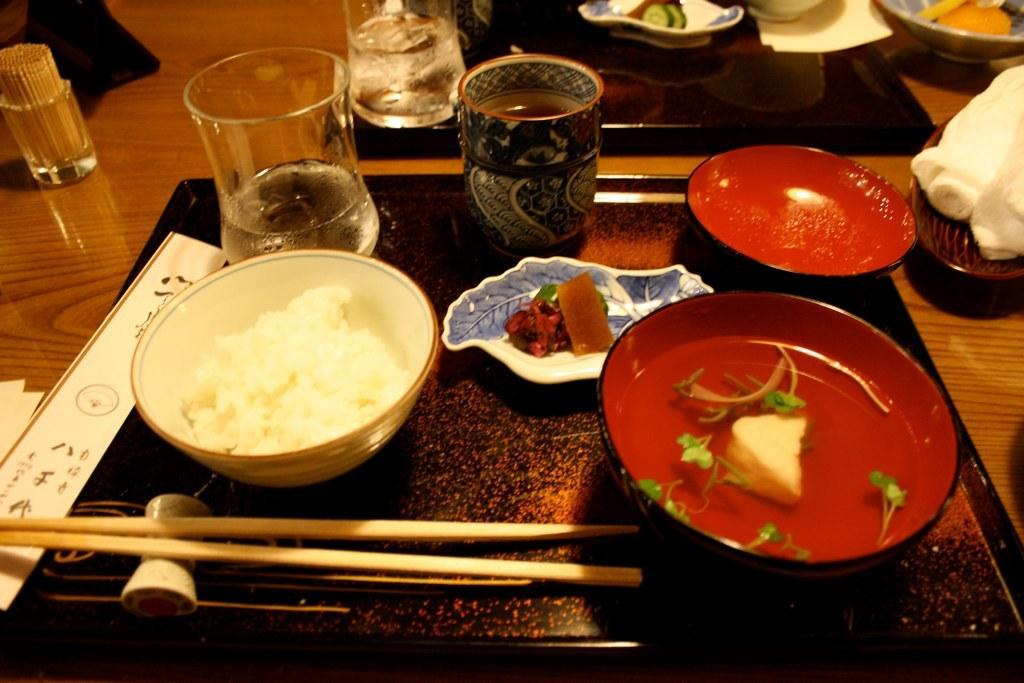What type of setting is shown in the image? The image depicts a dining table. What can be found on the table? There are bowls with food, a glass, a mug, chopsticks, a toothpick, a table mat, and a napkin on the table. Are there any utensils on the table? Yes, there are chopsticks on the table. What might be used for cleaning or wiping in the image? A napkin is present on the table for cleaning or wiping. What other unspecified items can be found on the table? There are other unspecified items on the table. What color is the fireman's hat in the image? There is no fireman or hat present in the image; it depicts a dining table with various items. Can you describe the playground equipment visible in the image? There is no playground equipment present in the image; it depicts a dining table with various items. 